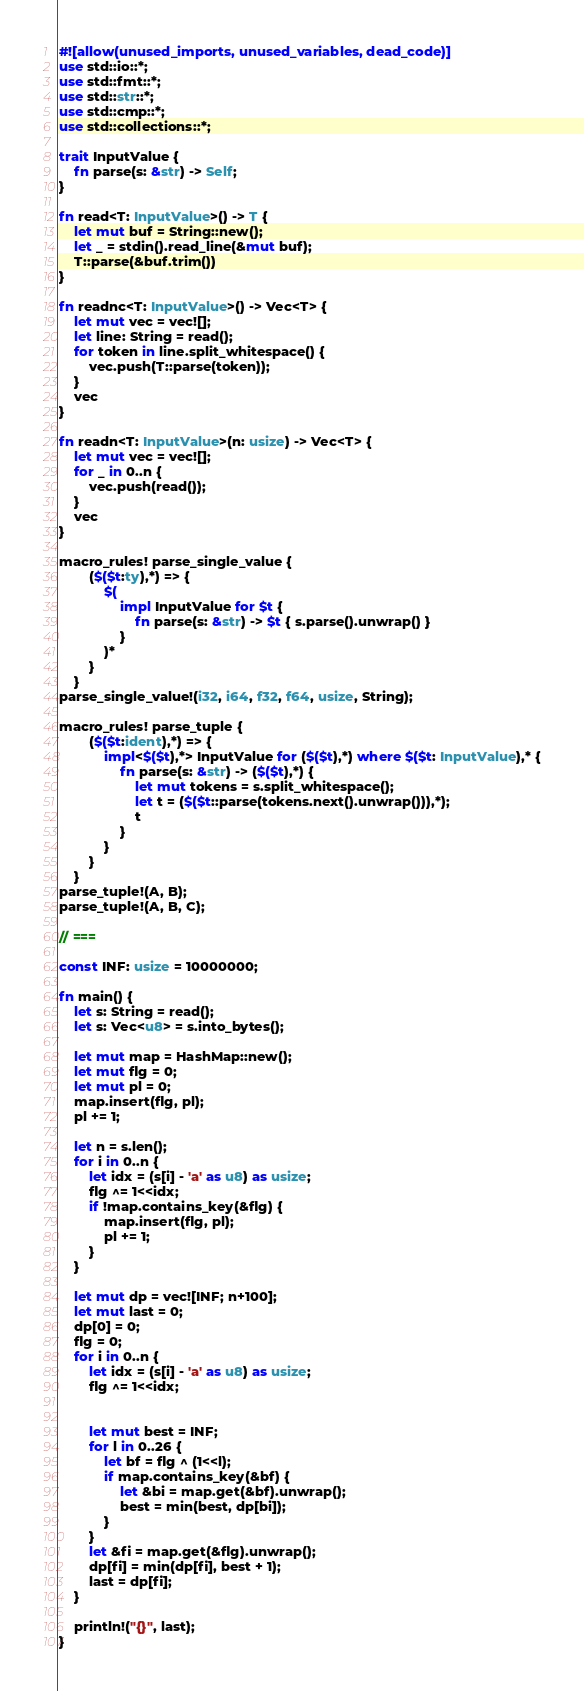<code> <loc_0><loc_0><loc_500><loc_500><_Rust_>#![allow(unused_imports, unused_variables, dead_code)]
use std::io::*;
use std::fmt::*;
use std::str::*;
use std::cmp::*;
use std::collections::*;

trait InputValue {
    fn parse(s: &str) -> Self;
}

fn read<T: InputValue>() -> T {
    let mut buf = String::new();
    let _ = stdin().read_line(&mut buf);
    T::parse(&buf.trim())
}

fn readnc<T: InputValue>() -> Vec<T> {
    let mut vec = vec![];
    let line: String = read();
    for token in line.split_whitespace() {
        vec.push(T::parse(token));
    }
    vec
}

fn readn<T: InputValue>(n: usize) -> Vec<T> {
    let mut vec = vec![];
    for _ in 0..n {
        vec.push(read());
    }
    vec
}

macro_rules! parse_single_value {
        ($($t:ty),*) => {
            $(
                impl InputValue for $t {
                    fn parse(s: &str) -> $t { s.parse().unwrap() }
                }
            )*
    	}
    }
parse_single_value!(i32, i64, f32, f64, usize, String);

macro_rules! parse_tuple {
    	($($t:ident),*) => {
    		impl<$($t),*> InputValue for ($($t),*) where $($t: InputValue),* {
    			fn parse(s: &str) -> ($($t),*) {
    				let mut tokens = s.split_whitespace();
    				let t = ($($t::parse(tokens.next().unwrap())),*);
    				t
    			}
    		}
    	}
    }
parse_tuple!(A, B);
parse_tuple!(A, B, C);

// ===

const INF: usize = 10000000;

fn main() {
    let s: String = read();
    let s: Vec<u8> = s.into_bytes();

    let mut map = HashMap::new();
    let mut flg = 0;
    let mut pl = 0;
    map.insert(flg, pl);
    pl += 1;

    let n = s.len();
    for i in 0..n {
        let idx = (s[i] - 'a' as u8) as usize;
        flg ^= 1<<idx;
        if !map.contains_key(&flg) {
            map.insert(flg, pl);
            pl += 1;
        }
    }

    let mut dp = vec![INF; n+100];
    let mut last = 0;
    dp[0] = 0;
    flg = 0;
    for i in 0..n {
        let idx = (s[i] - 'a' as u8) as usize;
        flg ^= 1<<idx;


        let mut best = INF;
        for l in 0..26 {
            let bf = flg ^ (1<<l);
            if map.contains_key(&bf) {
                let &bi = map.get(&bf).unwrap();
                best = min(best, dp[bi]);
            }
        }
        let &fi = map.get(&flg).unwrap();
        dp[fi] = min(dp[fi], best + 1);
        last = dp[fi];
    }

    println!("{}", last);
}</code> 